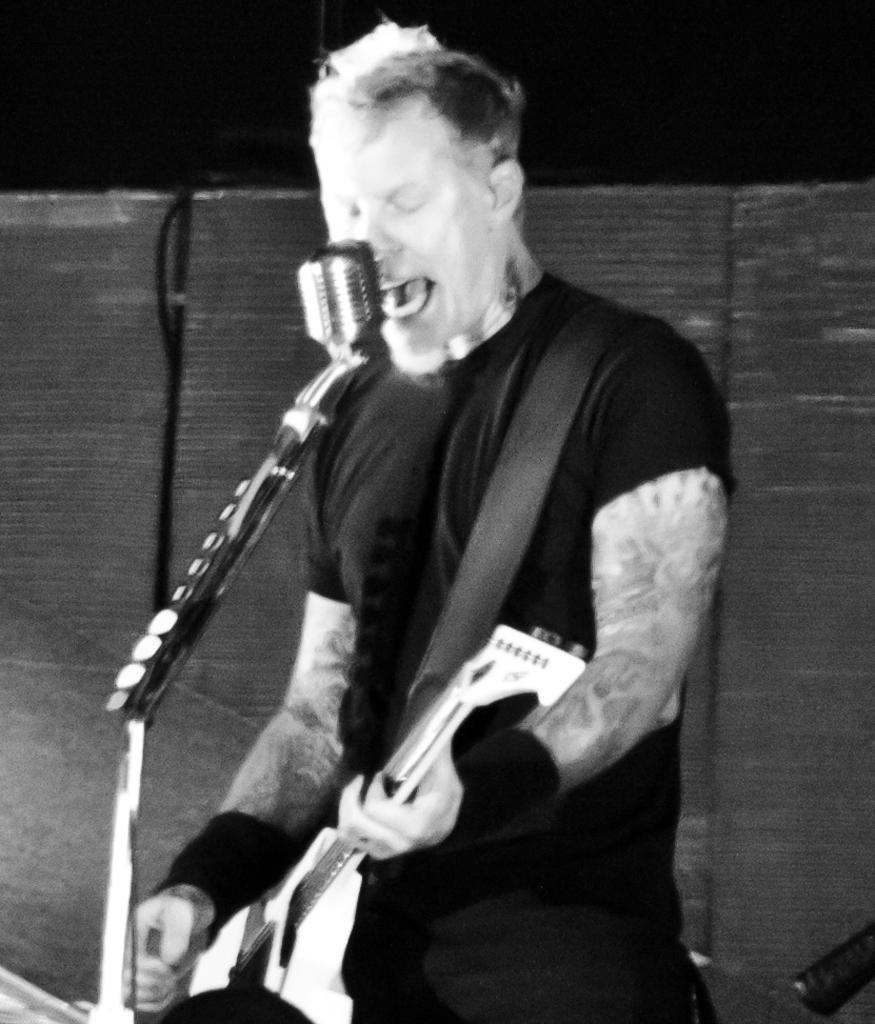What is the color scheme of the image? The image is black and white. Who is the main subject in the image? There is a man in the image. What is the man doing in the image? The man is standing in front of a microphone, playing a guitar, and singing. How many houses can be seen in the background of the image? There are no houses visible in the image, as it is a black and white image of a man playing a guitar and singing in front of a microphone. 